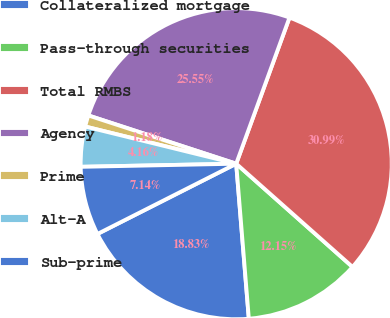Convert chart to OTSL. <chart><loc_0><loc_0><loc_500><loc_500><pie_chart><fcel>Collateralized mortgage<fcel>Pass-through securities<fcel>Total RMBS<fcel>Agency<fcel>Prime<fcel>Alt-A<fcel>Sub-prime<nl><fcel>18.83%<fcel>12.15%<fcel>30.98%<fcel>25.54%<fcel>1.18%<fcel>4.16%<fcel>7.14%<nl></chart> 